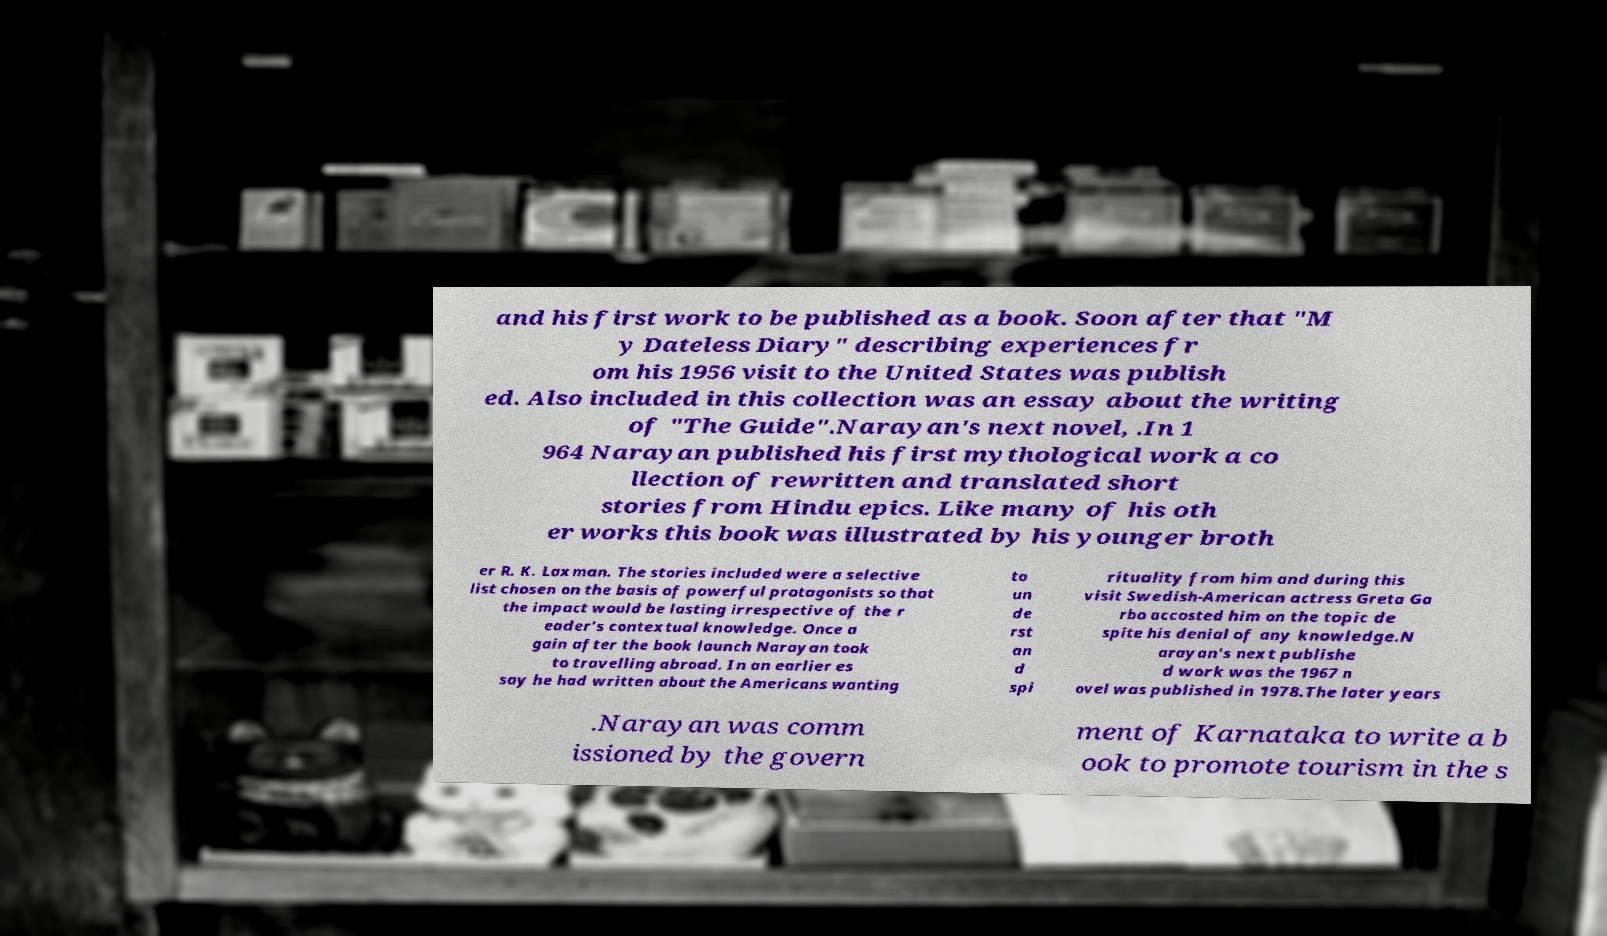Please identify and transcribe the text found in this image. and his first work to be published as a book. Soon after that "M y Dateless Diary" describing experiences fr om his 1956 visit to the United States was publish ed. Also included in this collection was an essay about the writing of "The Guide".Narayan's next novel, .In 1 964 Narayan published his first mythological work a co llection of rewritten and translated short stories from Hindu epics. Like many of his oth er works this book was illustrated by his younger broth er R. K. Laxman. The stories included were a selective list chosen on the basis of powerful protagonists so that the impact would be lasting irrespective of the r eader's contextual knowledge. Once a gain after the book launch Narayan took to travelling abroad. In an earlier es say he had written about the Americans wanting to un de rst an d spi rituality from him and during this visit Swedish-American actress Greta Ga rbo accosted him on the topic de spite his denial of any knowledge.N arayan's next publishe d work was the 1967 n ovel was published in 1978.The later years .Narayan was comm issioned by the govern ment of Karnataka to write a b ook to promote tourism in the s 